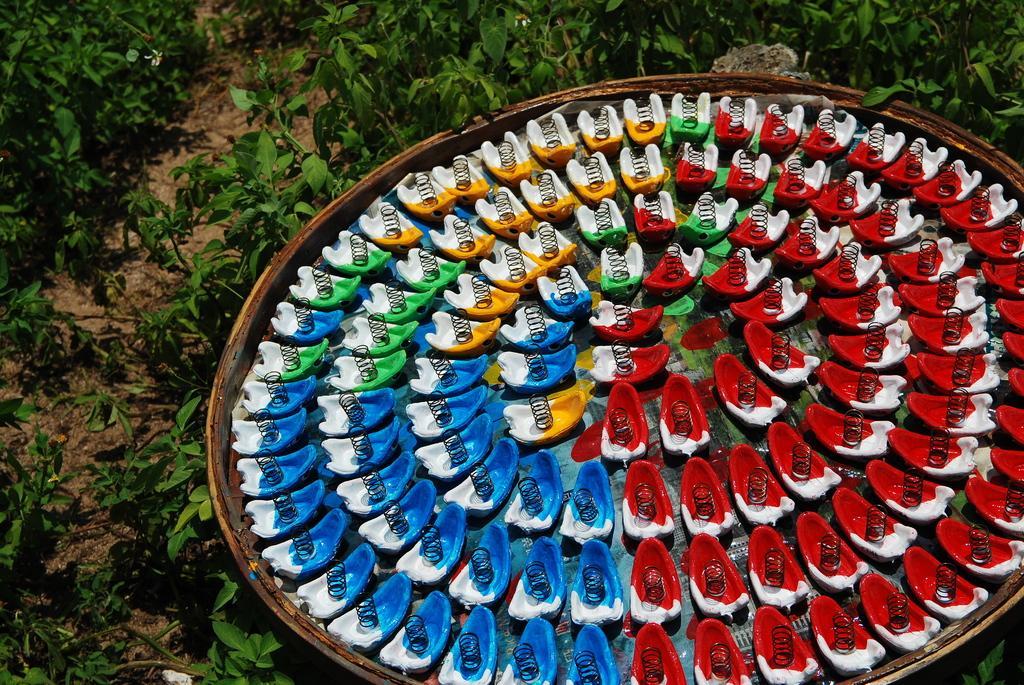Can you describe this image briefly? In this images we can see objects with springs on them and formed circles in a big plate. In the background there are plants on the ground. 